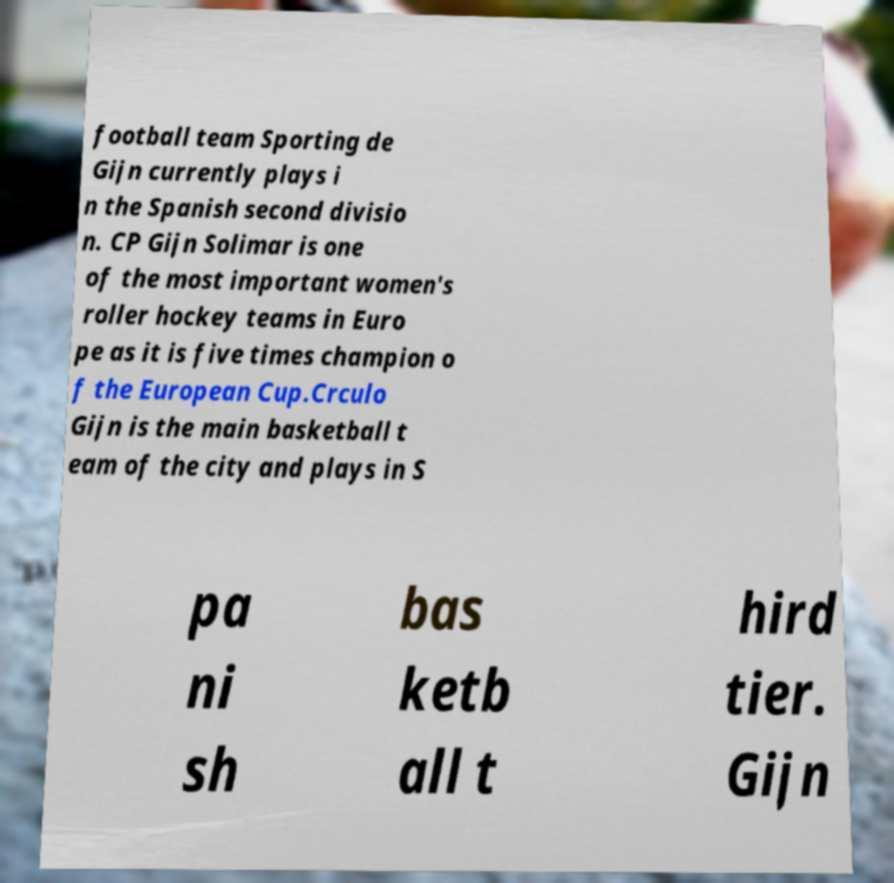Please identify and transcribe the text found in this image. football team Sporting de Gijn currently plays i n the Spanish second divisio n. CP Gijn Solimar is one of the most important women's roller hockey teams in Euro pe as it is five times champion o f the European Cup.Crculo Gijn is the main basketball t eam of the city and plays in S pa ni sh bas ketb all t hird tier. Gijn 